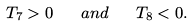Convert formula to latex. <formula><loc_0><loc_0><loc_500><loc_500>T _ { 7 } > 0 \quad a n d \quad T _ { 8 } < 0 .</formula> 